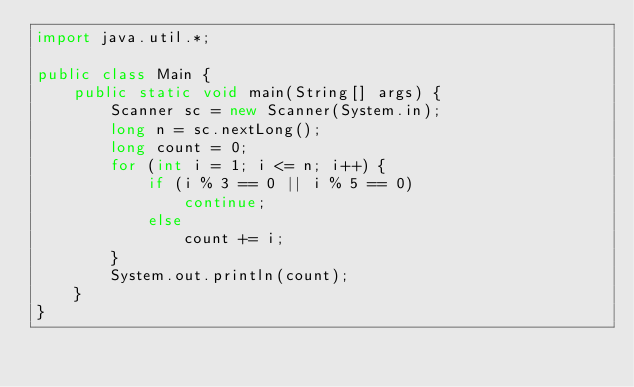<code> <loc_0><loc_0><loc_500><loc_500><_Java_>import java.util.*;

public class Main {
    public static void main(String[] args) {
        Scanner sc = new Scanner(System.in);
        long n = sc.nextLong();
        long count = 0;
        for (int i = 1; i <= n; i++) {
            if (i % 3 == 0 || i % 5 == 0)
                continue;
            else
                count += i;
        }
        System.out.println(count);
    }
}</code> 